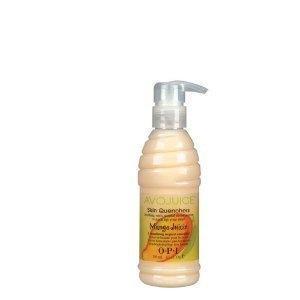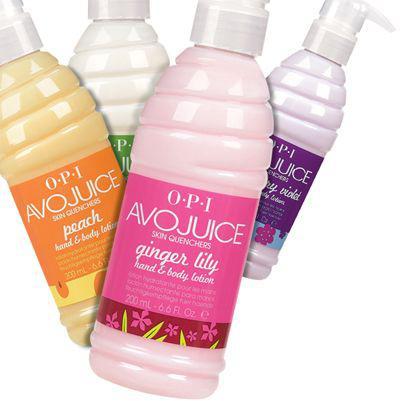The first image is the image on the left, the second image is the image on the right. For the images shown, is this caption "The left image features a single pump-top product." true? Answer yes or no. Yes. The first image is the image on the left, the second image is the image on the right. Evaluate the accuracy of this statement regarding the images: "At least four bottles of lotion are in one image, while the other image has just one pump bottle of lotion.". Is it true? Answer yes or no. Yes. 